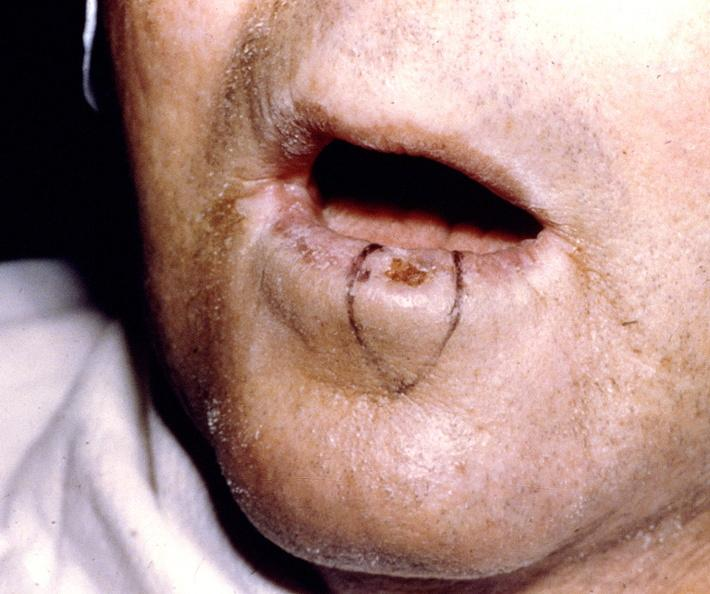s this photo of infant from head to toe present?
Answer the question using a single word or phrase. No 